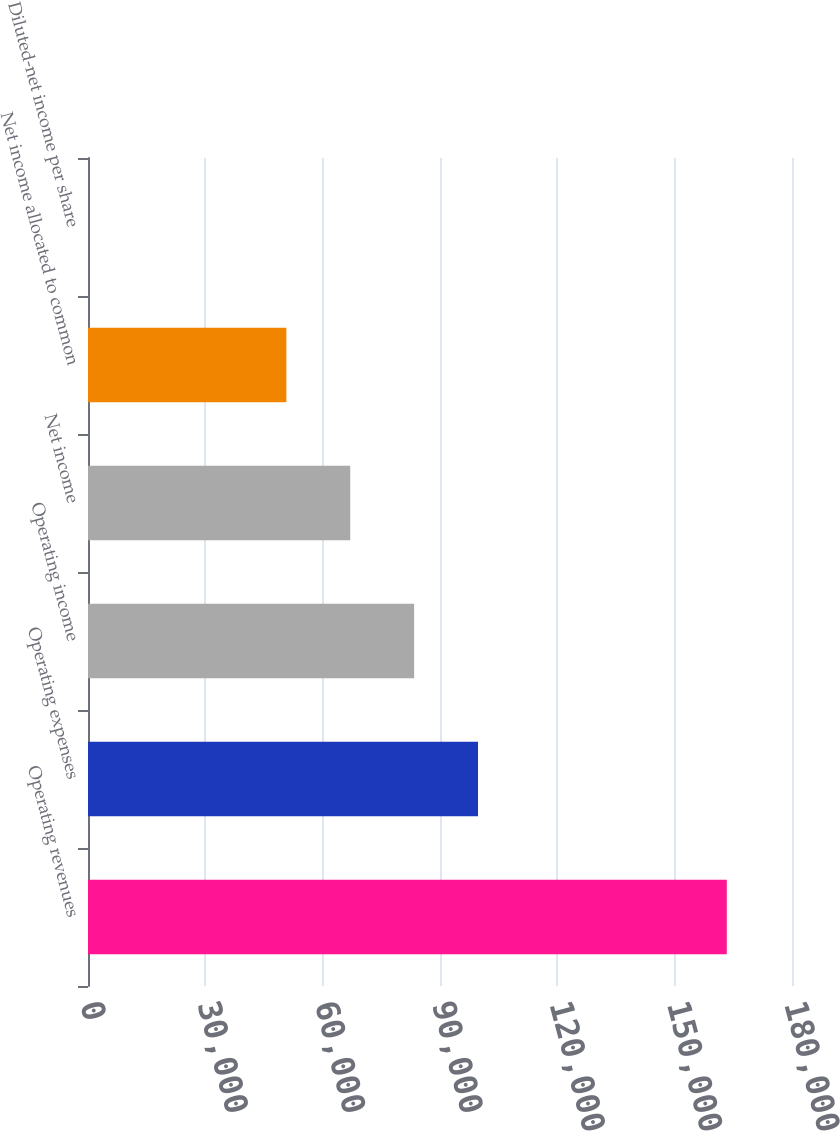Convert chart. <chart><loc_0><loc_0><loc_500><loc_500><bar_chart><fcel>Operating revenues<fcel>Operating expenses<fcel>Operating income<fcel>Net income<fcel>Net income allocated to common<fcel>Diluted-net income per share<nl><fcel>163329<fcel>99717.5<fcel>83384.7<fcel>67051.8<fcel>50719<fcel>0.62<nl></chart> 